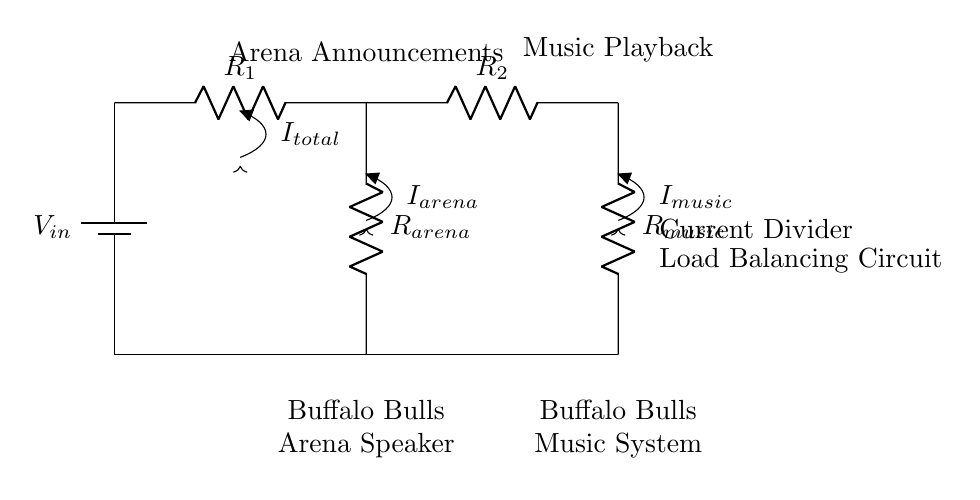What is the input voltage to the circuit? The input voltage is labeled as V_in in the circuit diagram, indicating it is connected to the battery.
Answer: V_in How many resistors are present in this circuit? The circuit shows three resistors: R_1, R_2, and the load resistors R_arena and R_music.
Answer: Four What components are connected to the arena announcements? The component connected to the arena announcements is labeled as R_arena, linked to the relevant section of the diagram.
Answer: R_arena What is the function of the current divider in this circuit? The current divider splits the total current into two paths, providing appropriate current levels to both the arena announcements and music playback components.
Answer: Load Balancing If the total current is represented as I_total, what is the relationship of I_arena to I_total? According to the current division principle, I_arena is a fraction of I_total depending on the values of R_arena and R_music. Specifically, I_arena = (R_music / (R_arena + R_music)) * I_total.
Answer: I_arena = (R_music / (R_arena + R_music)) * I_total What are the outputs for the current in the circuit? The circuit has two outputs for current, indicated by I_arena for the arena circuit and I_music for the music system circuit, which are derived from I_total.
Answer: I_arena and I_music What type of circuit is this? This circuit is a current divider circuit, designed specifically for load balancing purposes in audio systems.
Answer: Current Divider 